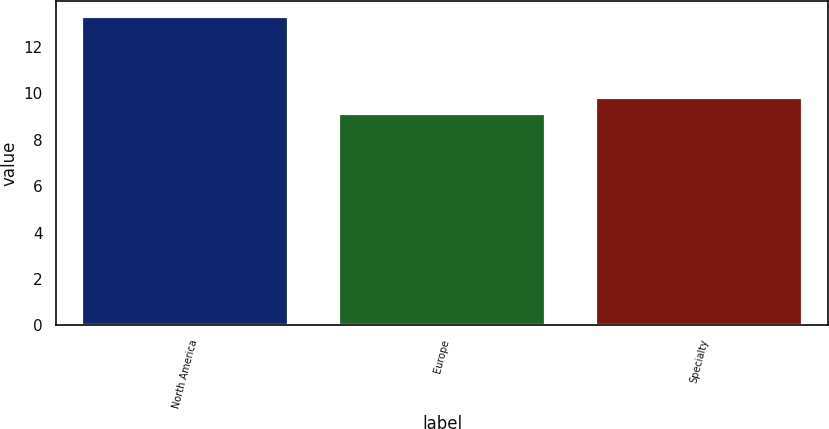Convert chart to OTSL. <chart><loc_0><loc_0><loc_500><loc_500><bar_chart><fcel>North America<fcel>Europe<fcel>Specialty<nl><fcel>13.3<fcel>9.1<fcel>9.8<nl></chart> 